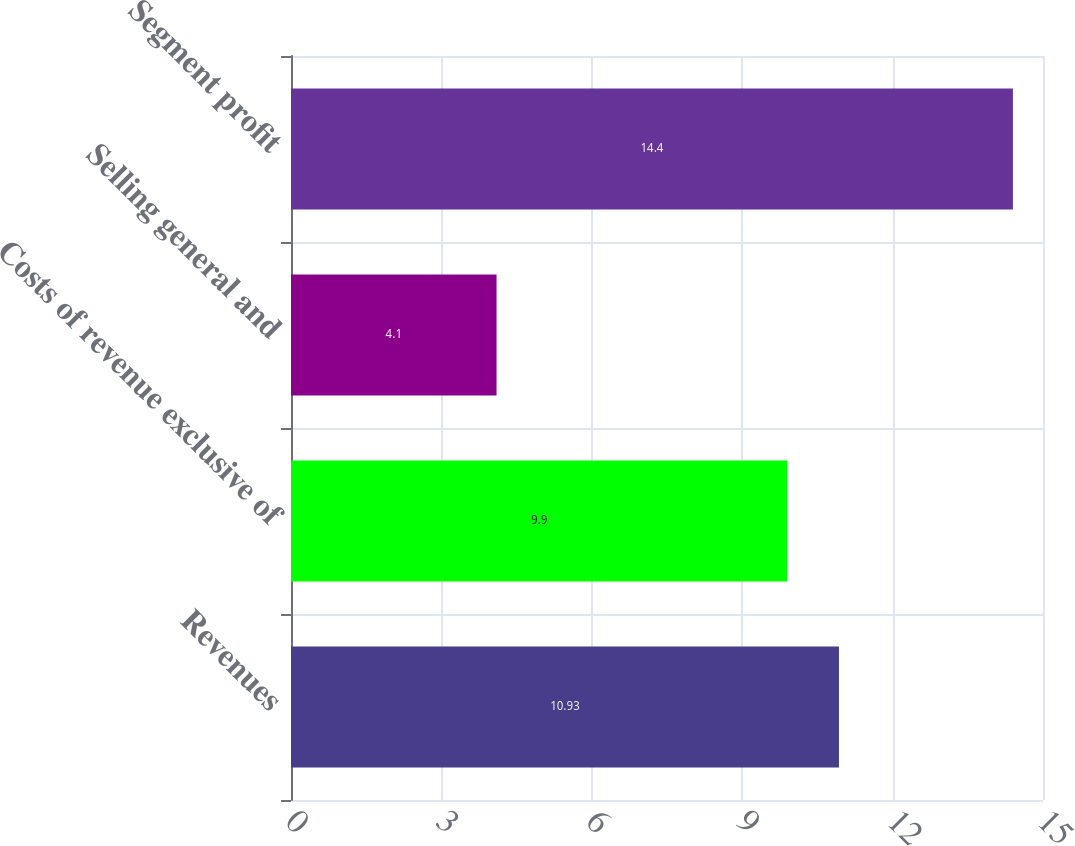Convert chart. <chart><loc_0><loc_0><loc_500><loc_500><bar_chart><fcel>Revenues<fcel>Costs of revenue exclusive of<fcel>Selling general and<fcel>Segment profit<nl><fcel>10.93<fcel>9.9<fcel>4.1<fcel>14.4<nl></chart> 